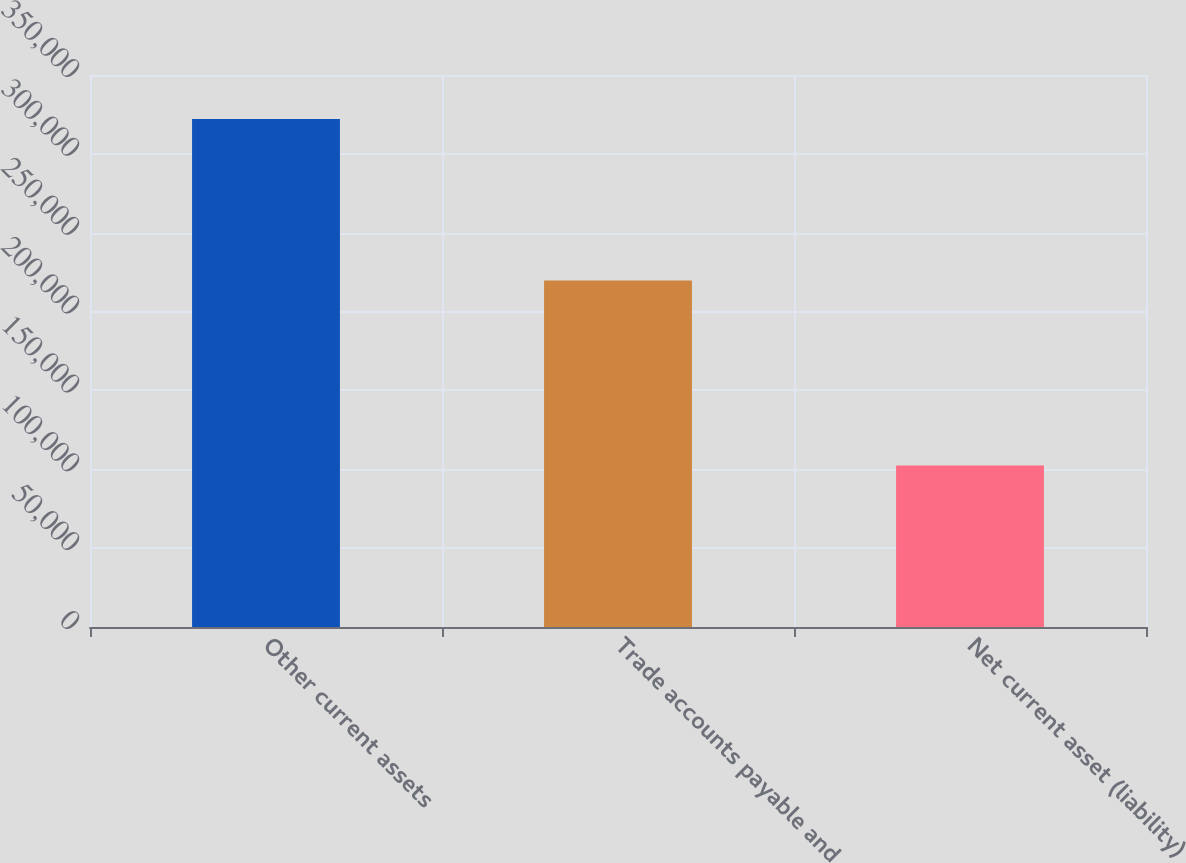Convert chart. <chart><loc_0><loc_0><loc_500><loc_500><bar_chart><fcel>Other current assets<fcel>Trade accounts payable and<fcel>Net current asset (liability)<nl><fcel>322108<fcel>219676<fcel>102432<nl></chart> 